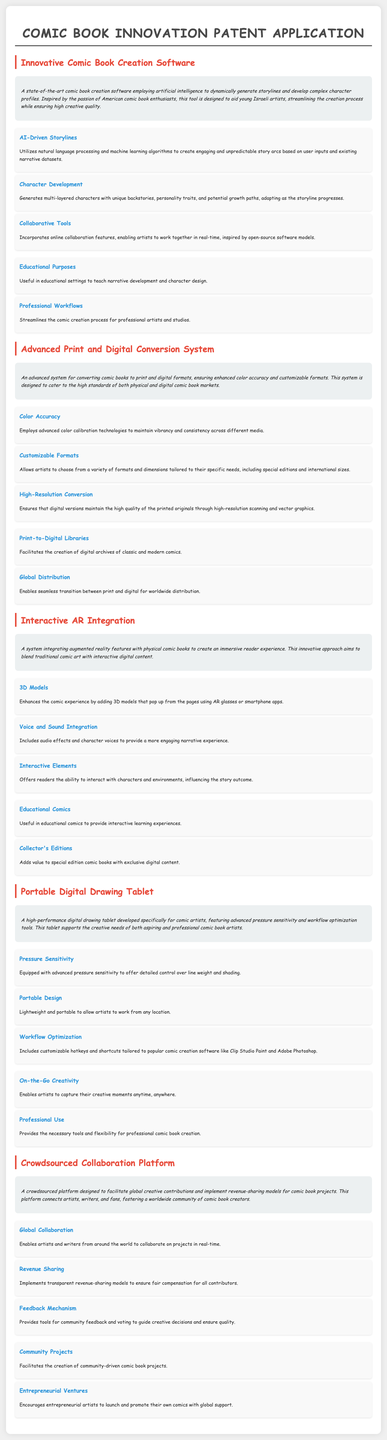what is the purpose of the innovative comic book creation software? The software aims to employ artificial intelligence to dynamically generate storylines and develop complex character profiles.
Answer: dynamically generate storylines and develop complex character profiles which technology is used for color accuracy in the conversion system? Advanced color calibration technologies are employed to maintain vibrancy and consistency across different media.
Answer: advanced color calibration technologies what interactive elements are included in the AR integration? Interactive elements allow readers to influence the story outcome.
Answer: influence the story outcome how does the portable digital drawing tablet help comic artists? It provides advanced pressure sensitivity and workflow optimization tools.
Answer: advanced pressure sensitivity and workflow optimization what is the role of the feedback mechanism in the crowdsourced platform? It provides tools for community feedback and voting to guide creative decisions.
Answer: guide creative decisions how does the collaboration platform ensure fair compensation? It implements transparent revenue-sharing models.
Answer: transparent revenue-sharing models what is one educational application of the innovative comic book creation software? Useful in educational settings to teach narrative development and character design.
Answer: educational settings to teach narrative development and character design what feature enhances the comic experience in the AR integration? 3D models that pop up from the pages enhance the comic experience.
Answer: 3D models that pop up from the pages which type of project does the crowdsourced platform facilitate? It facilitates the creation of community-driven comic book projects.
Answer: community-driven comic book projects 